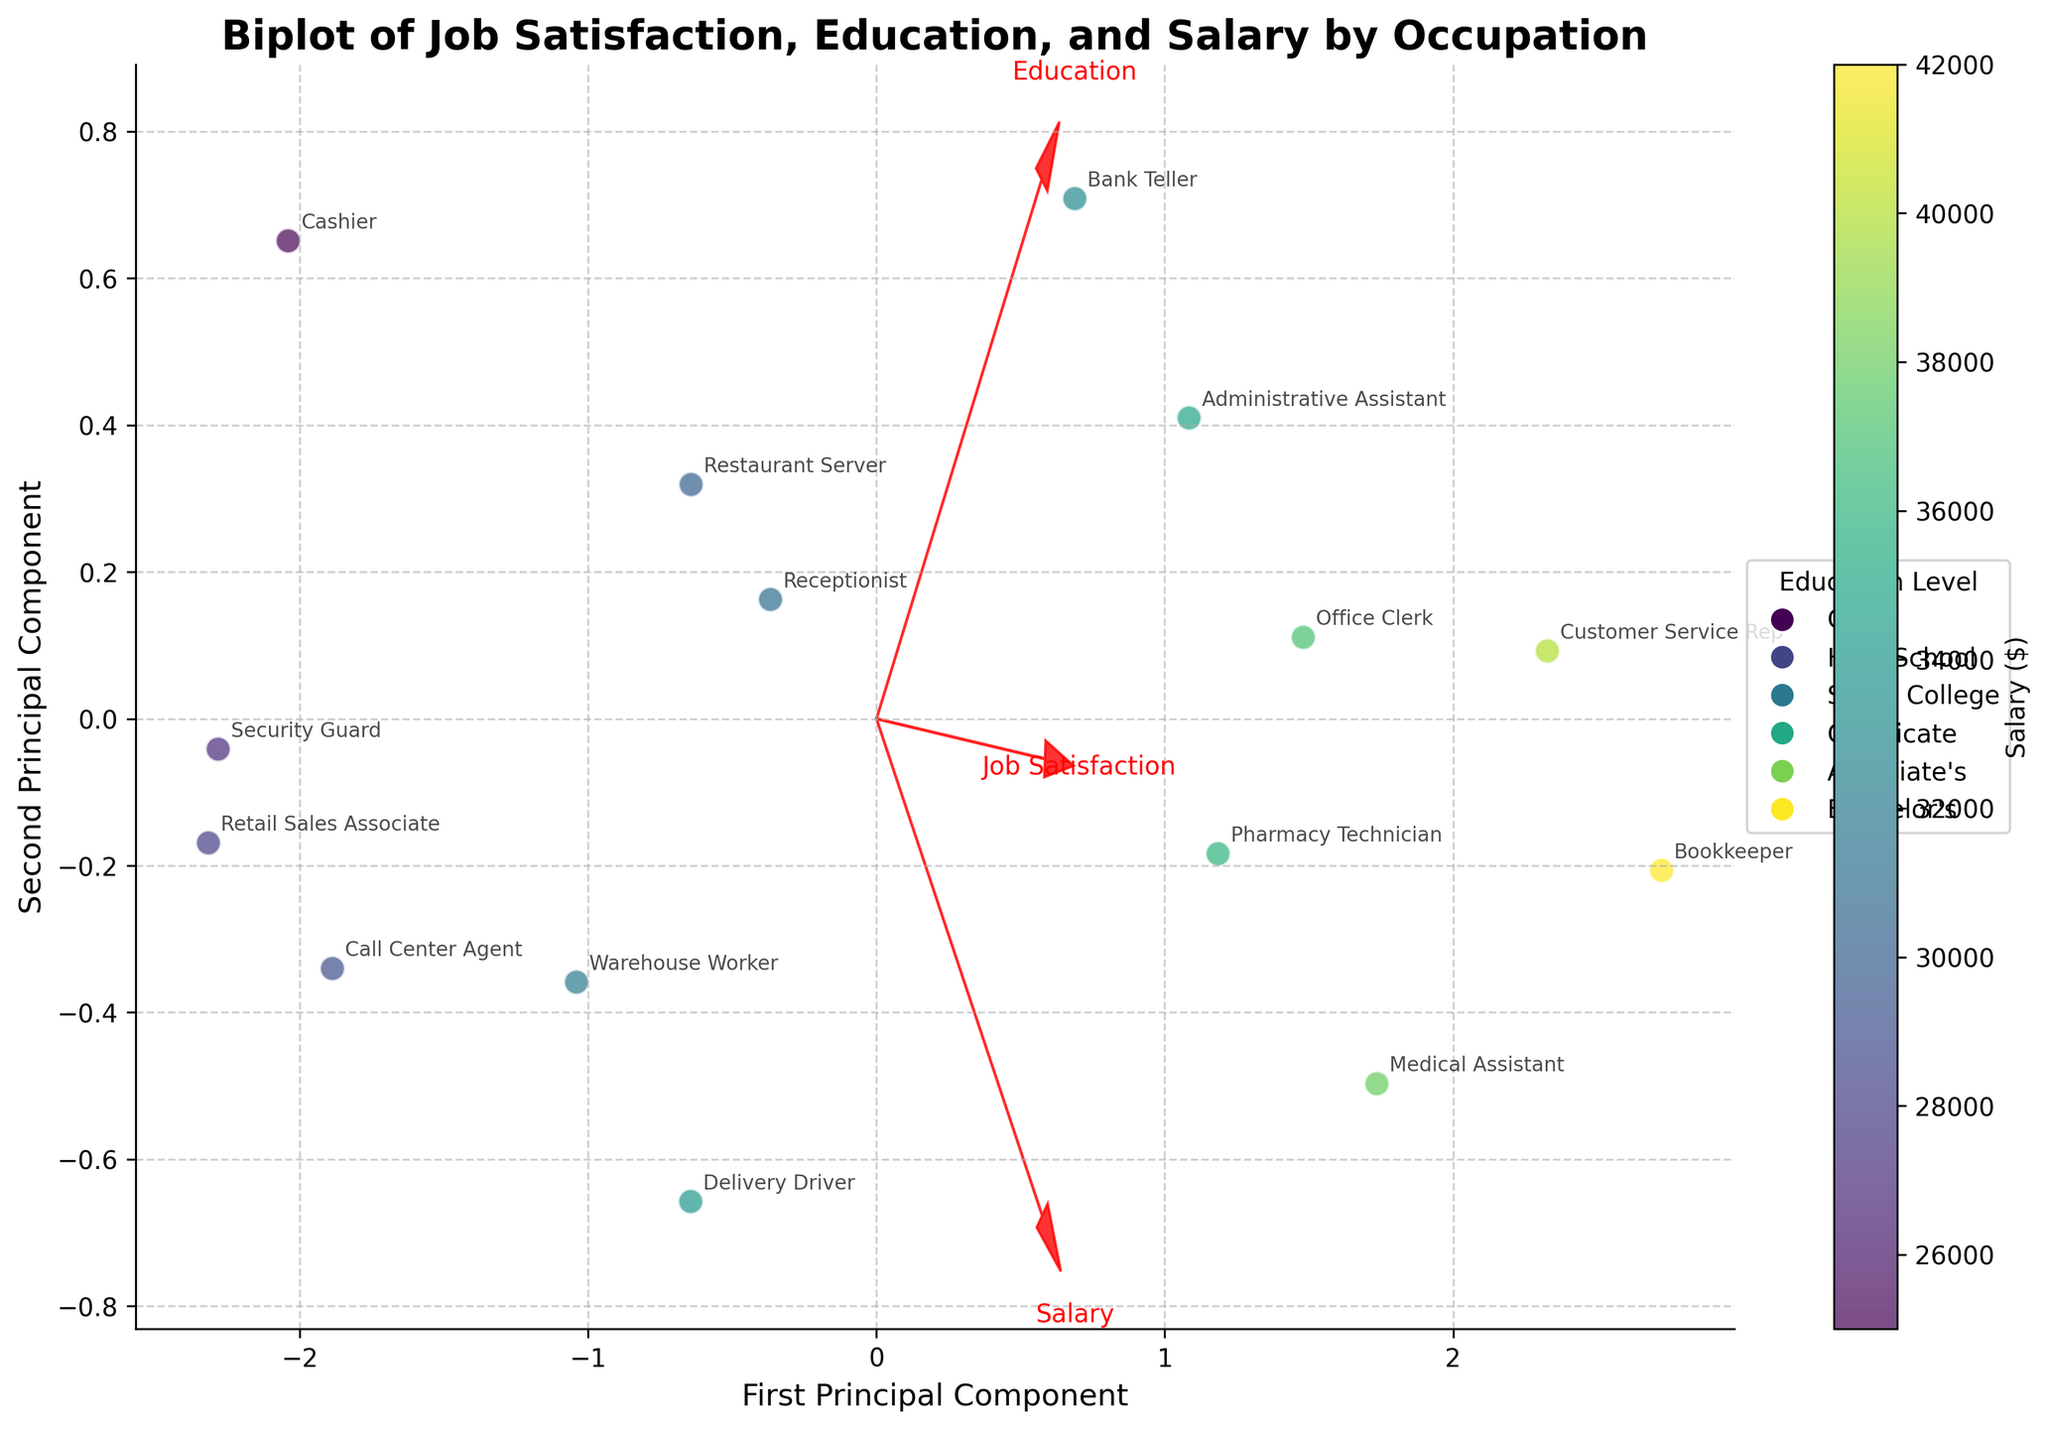What does the arrow direction represent on the biplot? The arrows in a biplot indicate the direction of the original features. For example, if an arrow points in a particular direction, it suggests that higher values of the feature it represents correlate with that direction on the PCA components.
Answer: Original feature directions What is the title of the biplot? The title of the biplot is typically displayed at the top of the figure and succinctly describes the plot. In this case, it is "Biplot of Job Satisfaction, Education, and Salary by Occupation".
Answer: Biplot of Job Satisfaction, Education, and Salary by Occupation How many arrows are plotted in this biplot? The figure displays arrows for each original feature included in the PCA. In this plot, there are three features: Education, Job Satisfaction, and Salary. Hence, there are 3 arrows plotted.
Answer: 3 Which occupation appears to have the highest job satisfaction based on the plot? The occupations are annotated near the points in the biplot. By looking at the annotations and their corresponding positions related to the 'Job Satisfaction' direction, the occupation Medical Assistant appears to have the highest job satisfaction.
Answer: Medical Assistant How does the position of 'Bookkeeper' compare to 'Call Center Agent' in the context of education and salary? By examining the biplot, you analyze the relative positions of the 'Bookkeeper' and 'Call Center Agent'. The 'Bookkeeper' is situated farther along the Education and Salary directions, indicating higher qualifications and salary compared to the 'Call Center Agent'.
Answer: Bookkeeper has higher education and salary Which direction does the 'Salary' vector point to? The 'Salary' vector direction can be identified by looking at the arrow labeled 'Salary'. It's pointing in a certain direction on the 2D plane, indicating higher values of salary correlate in that direction.
Answer: To the right and upward What is the general relationship between education level and job satisfaction as depicted by the arrows? The relative angles and directions of the 'Education' and 'Job Satisfaction' vectors in the biplot indicate their correlations. If the arrows are close to each other, the correlation is strong and positive; if they are perpendicular, the relationship is weak or none. Here, they point in similar directions indicating a positive correlation.
Answer: Positive correlation Which occupation is closest to the origin, and what might this imply? The origin represents the mean-centered value of the features. By finding the occupation closest to the origin, you identify it as 'Administrative Assistant', which could imply average values across the plotted features.
Answer: Administrative Assistant Between 'Customer Service Rep' and 'Warehouse Worker', which has a higher perceived job satisfaction? By comparing their annotations with the direction of the 'Job Satisfaction' vector, it is clear that 'Customer Service Rep' is positioned closer to the higher job satisfaction direction.
Answer: Customer Service Rep 